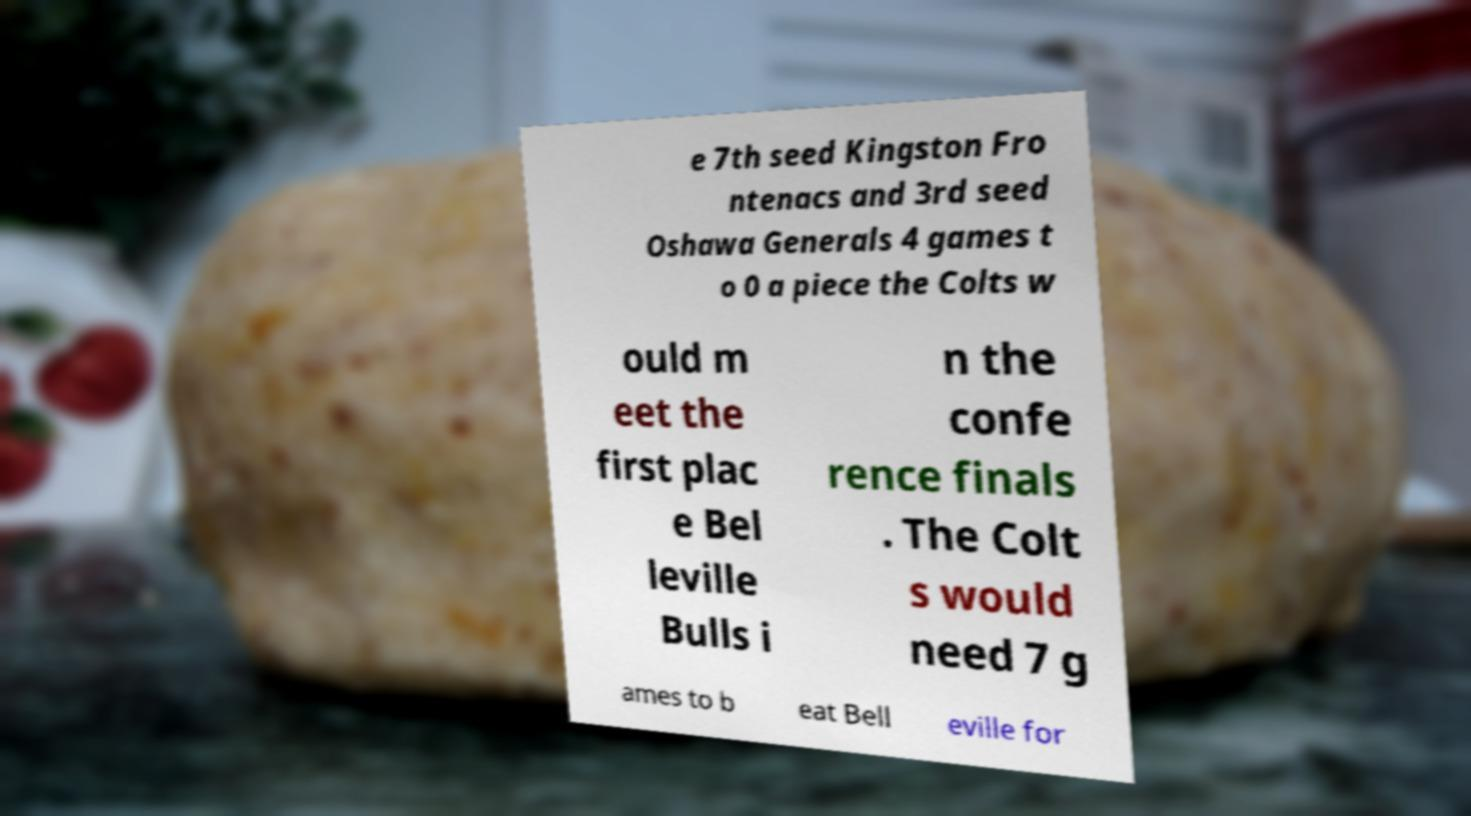There's text embedded in this image that I need extracted. Can you transcribe it verbatim? e 7th seed Kingston Fro ntenacs and 3rd seed Oshawa Generals 4 games t o 0 a piece the Colts w ould m eet the first plac e Bel leville Bulls i n the confe rence finals . The Colt s would need 7 g ames to b eat Bell eville for 